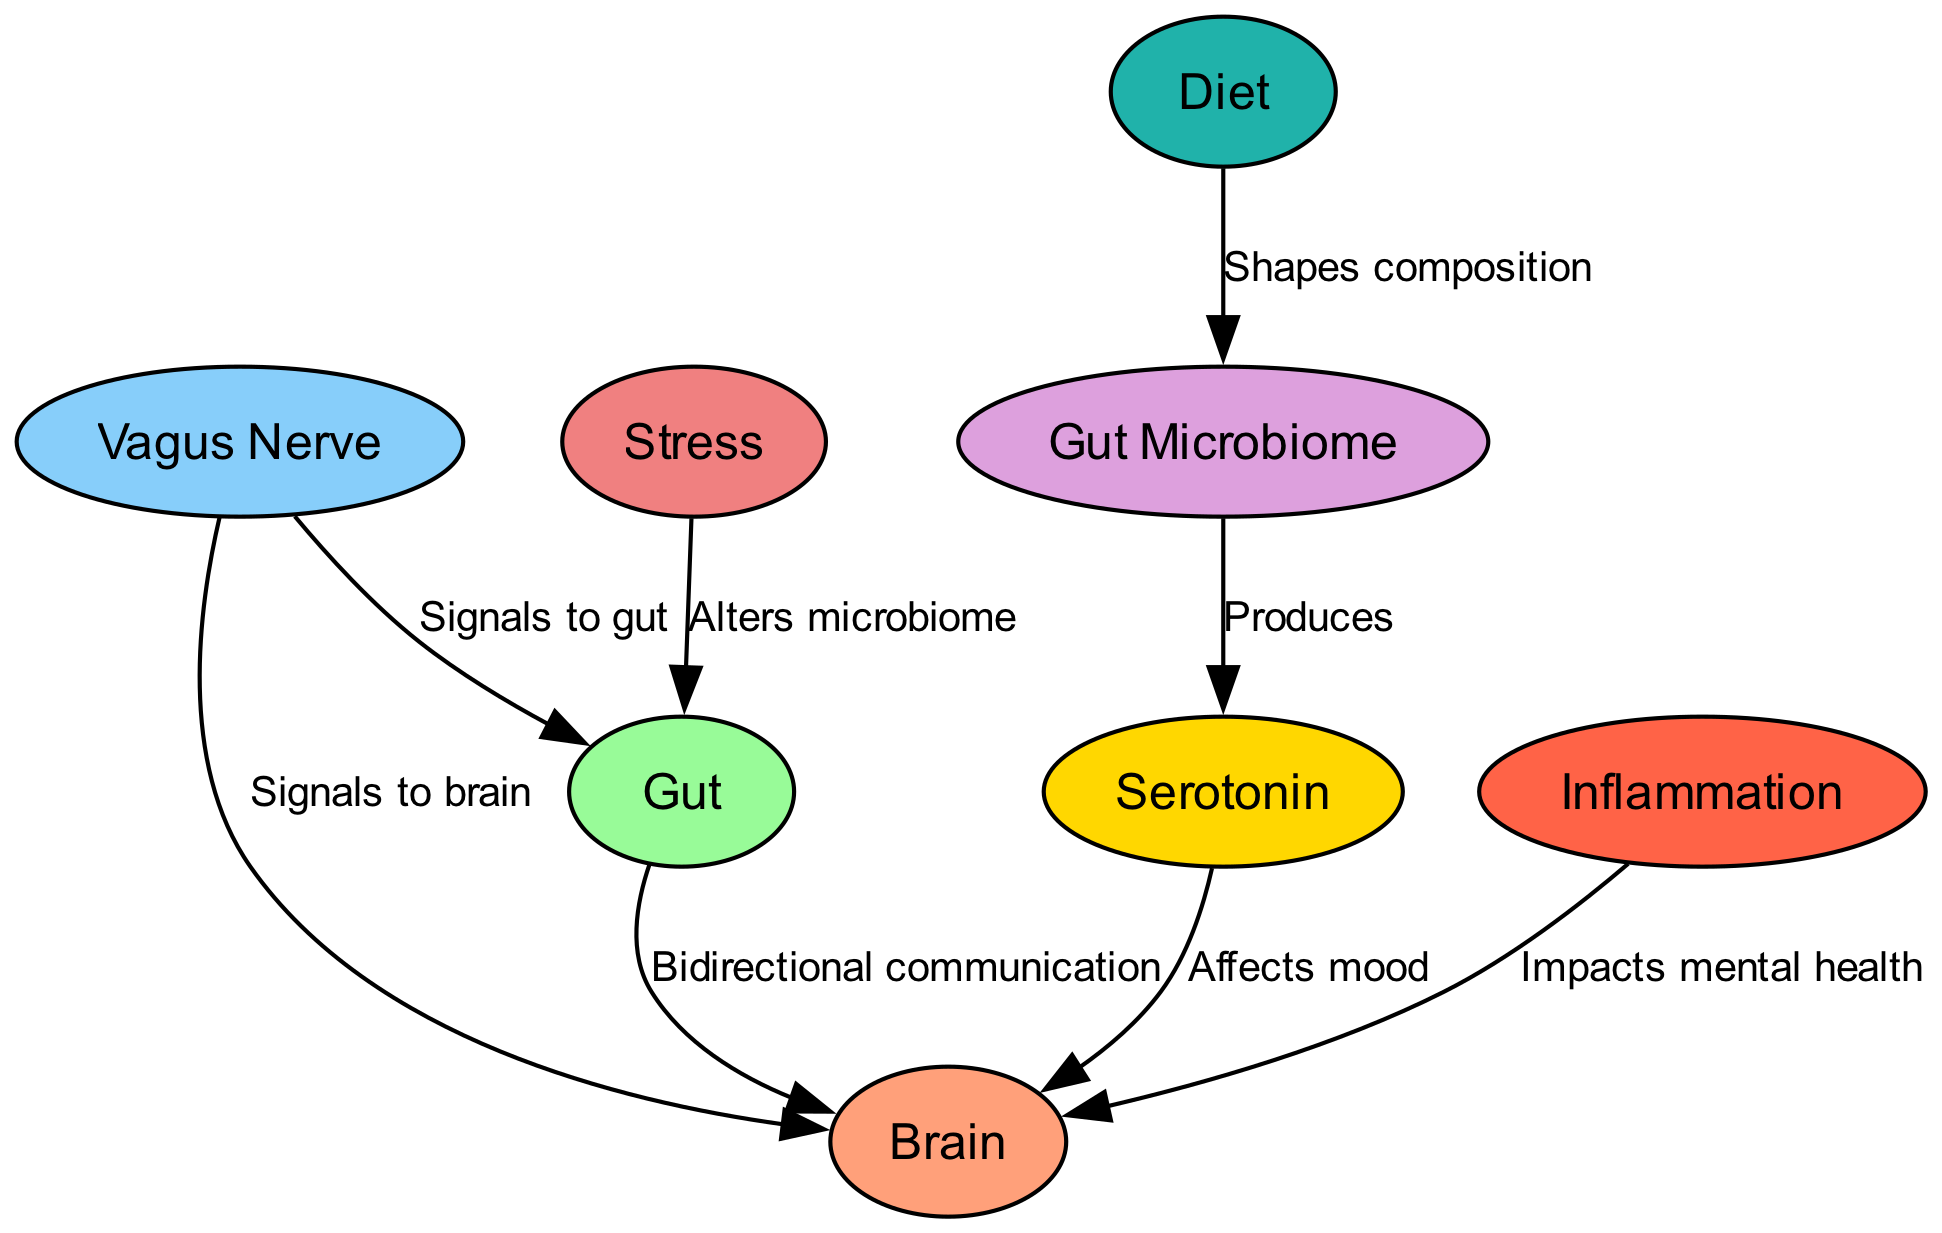How many nodes are in the diagram? The diagram has a total of 8 nodes representing key components in the gut-brain connection, which include Brain, Gut, Vagus Nerve, Gut Microbiome, Serotonin, Inflammation, Stress, and Diet.
Answer: 8 What does the Gut Microbiome produce? The diagram indicates that the Gut Microbiome produces Serotonin, which is depicted as a directed edge from the microbiome to serotonin in the diagram.
Answer: Serotonin How does stress affect the gut? According to the diagram, stress alters the microbiome, shown by the direct connection from stress to gut. This indicates a negative impact of stress on gut health.
Answer: Alters microbiome Which node is affected by inflammation? The diagram shows that inflammation impacts mental health, specifically affecting the Brain, which is indicated by a directed edge from inflammation to brain.
Answer: Brain What is the relationship between diet and gut microbiome? The relationship is shown in the diagram as diet shapes the composition of the gut microbiome, indicated by the directed edge from diet to microbiome.
Answer: Shapes composition How many edges are in the diagram? The diagram contains 8 edges, which represent the various relationships and interactions between the nodes in the gut-brain connection.
Answer: 8 How does the Vagus Nerve communicate with the brain? The diagram specifies that the Vagus Nerve sends signals to the brain, which is depicted by the directed edge from the vagus nerve to the brain.
Answer: Signals to brain What affects mood according to the diagram? The diagram shows that Serotonin affects mood, indicated by the edge from serotonin to brain, implying a direct influence on mental state.
Answer: Affects mood How does the gut communicate with the brain? The diagram illustrates bidirectional communication between the gut and the brain, represented by a connection that allows for two-way signaling.
Answer: Bidirectional communication 